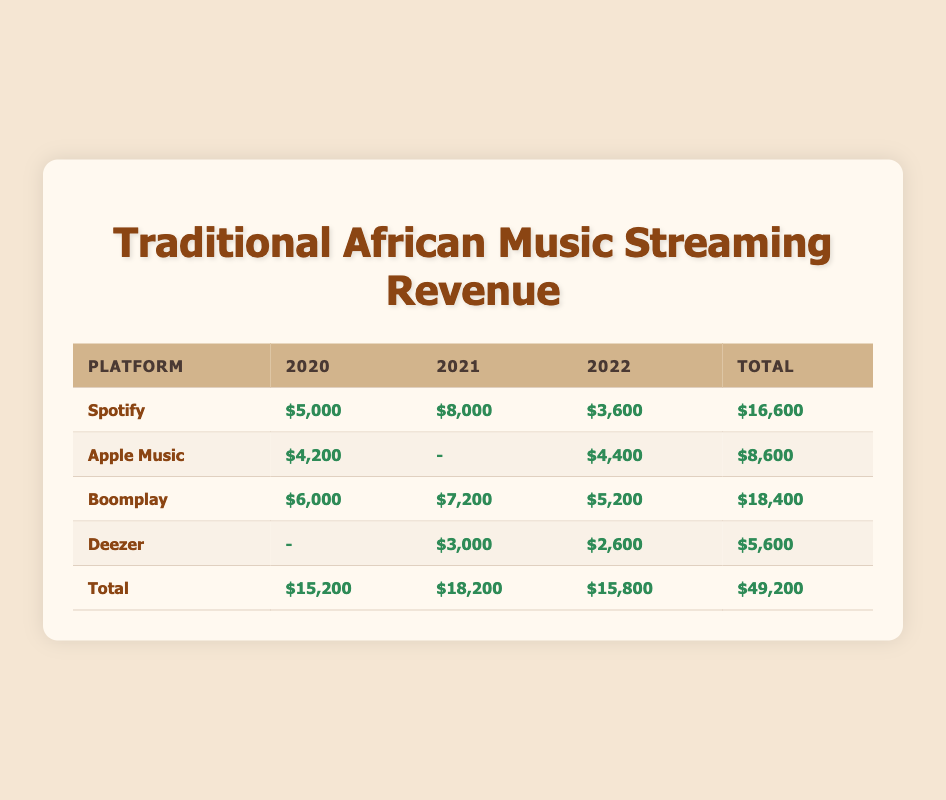What was the total revenue generated by Spotify in 2021? Looking at the table, Spotify's revenue for 2021 is listed directly as $8,000.
Answer: 8000 Which platform had the highest total revenue over the three years? From the total revenues at the bottom of the table, Boomplay has the highest total revenue of $18,400 compared to the others.
Answer: Boomplay Was there any revenue generated by Deezer in 2020? The table indicates that the revenue for Deezer in 2020 is listed as "-", which means there was no revenue generated.
Answer: No What is the total revenue generated by all platforms in 2022? The total revenue for 2022 can be calculated by adding up the revenue of all platforms: $3,600 (Spotify) + $4,400 (Apple Music) + $5,200 (Boomplay) + $2,600 (Deezer) = $15,800.
Answer: 15800 What is the average revenue generated by Apple Music over the three years? The revenues for Apple Music are $4,200 in 2020, "-" in 2021, and $4,400 in 2022. To calculate the average, we consider only the two values (since one year has no revenue) summing them up gives $4,200 + $4,400 = $8,600; then dividing by 2 (the number of years with data) results in an average of $4,300.
Answer: 4300 How much more revenue did Boomplay generate than Spotify in 2020? Boomplay's revenue for 2020 is $6,000 while Spotify's is $5,000. Therefore, the difference is $6,000 - $5,000 = $1,000.
Answer: 1000 Did any platform report revenue in all three years? By checking the table, we see that Boomplay has recorded revenue in all three years: $6,000 (2020), $7,200 (2021), and $5,200 (2022).
Answer: Yes What is the total revenue difference between the two platforms, Boomplay and Deezer, over the three years? Boomplay's total revenue is $18,400 and Deezer's is $5,600. The difference is $18,400 - $5,600 = $12,800.
Answer: 12800 